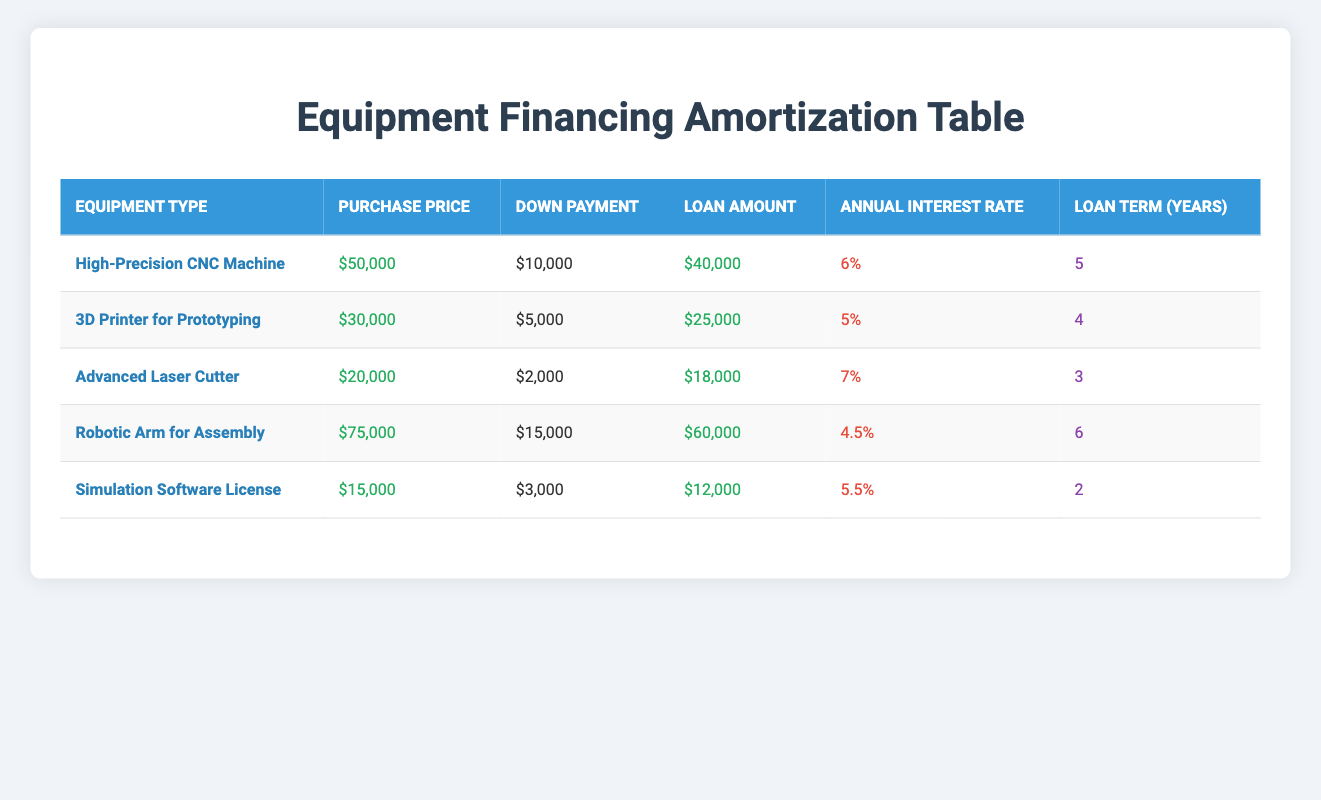What is the loan amount for the High-Precision CNC Machine? The loan amount for the High-Precision CNC Machine is explicitly stated in the table as $40,000.
Answer: $40,000 What is the annual interest rate for the 3D Printer for Prototyping? The annual interest rate for the 3D Printer for Prototyping is clearly mentioned in the table as 5%.
Answer: 5% How much is the down payment for the Advanced Laser Cutter? The down payment for the Advanced Laser Cutter is specified in the table as $2,000.
Answer: $2,000 Which equipment has the highest purchase price? By comparing the purchase prices listed for each equipment type, the Robotic Arm for Assembly has the highest purchase price at $75,000.
Answer: Robotic Arm for Assembly What is the total loan amount for all equipment listed? To find the total loan amount, we sum the loan amounts of each piece of equipment: $40,000 + $25,000 + $18,000 + $60,000 + $12,000 = $155,000.
Answer: $155,000 Is the annual interest rate for the Simulation Software License greater than 5%? The annual interest rate for the Simulation Software License is 5.5%, which is greater than 5%. Therefore, the statement is true.
Answer: True What is the difference in purchase price between the High-Precision CNC Machine and the Advanced Laser Cutter? The purchase price of the High-Precision CNC Machine is $50,000 and that of the Advanced Laser Cutter is $20,000. The difference is calculated as $50,000 - $20,000 = $30,000.
Answer: $30,000 Which equipment has a loan term of 4 years, and what is its loan amount? The 3D Printer for Prototyping has a loan term of 4 years, with a loan amount of $25,000, as specified in the table.
Answer: 3D Printer for Prototyping, $25,000 What is the average down payment across all listed equipment? To calculate the average down payment, we must first sum the down payments: $10,000 + $5,000 + $2,000 + $15,000 + $3,000 = $35,000, then divide by the number of equipment (5): $35,000 / 5 = $7,000.
Answer: $7,000 Which equipment has the lowest annual interest rate, and what is that rate? By examining the annual interest rates, the Robotic Arm for Assembly has the lowest rate at 4.5%.
Answer: Robotic Arm for Assembly, 4.5% 